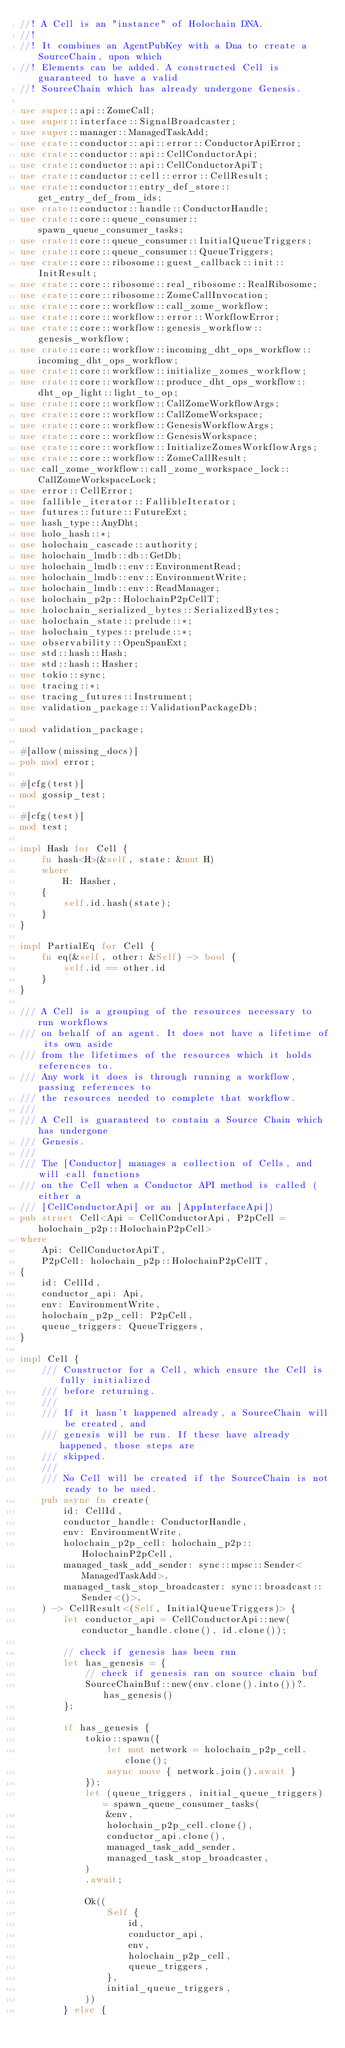<code> <loc_0><loc_0><loc_500><loc_500><_Rust_>//! A Cell is an "instance" of Holochain DNA.
//!
//! It combines an AgentPubKey with a Dna to create a SourceChain, upon which
//! Elements can be added. A constructed Cell is guaranteed to have a valid
//! SourceChain which has already undergone Genesis.

use super::api::ZomeCall;
use super::interface::SignalBroadcaster;
use super::manager::ManagedTaskAdd;
use crate::conductor::api::error::ConductorApiError;
use crate::conductor::api::CellConductorApi;
use crate::conductor::api::CellConductorApiT;
use crate::conductor::cell::error::CellResult;
use crate::conductor::entry_def_store::get_entry_def_from_ids;
use crate::conductor::handle::ConductorHandle;
use crate::core::queue_consumer::spawn_queue_consumer_tasks;
use crate::core::queue_consumer::InitialQueueTriggers;
use crate::core::queue_consumer::QueueTriggers;
use crate::core::ribosome::guest_callback::init::InitResult;
use crate::core::ribosome::real_ribosome::RealRibosome;
use crate::core::ribosome::ZomeCallInvocation;
use crate::core::workflow::call_zome_workflow;
use crate::core::workflow::error::WorkflowError;
use crate::core::workflow::genesis_workflow::genesis_workflow;
use crate::core::workflow::incoming_dht_ops_workflow::incoming_dht_ops_workflow;
use crate::core::workflow::initialize_zomes_workflow;
use crate::core::workflow::produce_dht_ops_workflow::dht_op_light::light_to_op;
use crate::core::workflow::CallZomeWorkflowArgs;
use crate::core::workflow::CallZomeWorkspace;
use crate::core::workflow::GenesisWorkflowArgs;
use crate::core::workflow::GenesisWorkspace;
use crate::core::workflow::InitializeZomesWorkflowArgs;
use crate::core::workflow::ZomeCallResult;
use call_zome_workflow::call_zome_workspace_lock::CallZomeWorkspaceLock;
use error::CellError;
use fallible_iterator::FallibleIterator;
use futures::future::FutureExt;
use hash_type::AnyDht;
use holo_hash::*;
use holochain_cascade::authority;
use holochain_lmdb::db::GetDb;
use holochain_lmdb::env::EnvironmentRead;
use holochain_lmdb::env::EnvironmentWrite;
use holochain_lmdb::env::ReadManager;
use holochain_p2p::HolochainP2pCellT;
use holochain_serialized_bytes::SerializedBytes;
use holochain_state::prelude::*;
use holochain_types::prelude::*;
use observability::OpenSpanExt;
use std::hash::Hash;
use std::hash::Hasher;
use tokio::sync;
use tracing::*;
use tracing_futures::Instrument;
use validation_package::ValidationPackageDb;

mod validation_package;

#[allow(missing_docs)]
pub mod error;

#[cfg(test)]
mod gossip_test;

#[cfg(test)]
mod test;

impl Hash for Cell {
    fn hash<H>(&self, state: &mut H)
    where
        H: Hasher,
    {
        self.id.hash(state);
    }
}

impl PartialEq for Cell {
    fn eq(&self, other: &Self) -> bool {
        self.id == other.id
    }
}

/// A Cell is a grouping of the resources necessary to run workflows
/// on behalf of an agent. It does not have a lifetime of its own aside
/// from the lifetimes of the resources which it holds references to.
/// Any work it does is through running a workflow, passing references to
/// the resources needed to complete that workflow.
///
/// A Cell is guaranteed to contain a Source Chain which has undergone
/// Genesis.
///
/// The [Conductor] manages a collection of Cells, and will call functions
/// on the Cell when a Conductor API method is called (either a
/// [CellConductorApi] or an [AppInterfaceApi])
pub struct Cell<Api = CellConductorApi, P2pCell = holochain_p2p::HolochainP2pCell>
where
    Api: CellConductorApiT,
    P2pCell: holochain_p2p::HolochainP2pCellT,
{
    id: CellId,
    conductor_api: Api,
    env: EnvironmentWrite,
    holochain_p2p_cell: P2pCell,
    queue_triggers: QueueTriggers,
}

impl Cell {
    /// Constructor for a Cell, which ensure the Cell is fully initialized
    /// before returning.
    ///
    /// If it hasn't happened already, a SourceChain will be created, and
    /// genesis will be run. If these have already happened, those steps are
    /// skipped.
    ///
    /// No Cell will be created if the SourceChain is not ready to be used.
    pub async fn create(
        id: CellId,
        conductor_handle: ConductorHandle,
        env: EnvironmentWrite,
        holochain_p2p_cell: holochain_p2p::HolochainP2pCell,
        managed_task_add_sender: sync::mpsc::Sender<ManagedTaskAdd>,
        managed_task_stop_broadcaster: sync::broadcast::Sender<()>,
    ) -> CellResult<(Self, InitialQueueTriggers)> {
        let conductor_api = CellConductorApi::new(conductor_handle.clone(), id.clone());

        // check if genesis has been run
        let has_genesis = {
            // check if genesis ran on source chain buf
            SourceChainBuf::new(env.clone().into())?.has_genesis()
        };

        if has_genesis {
            tokio::spawn({
                let mut network = holochain_p2p_cell.clone();
                async move { network.join().await }
            });
            let (queue_triggers, initial_queue_triggers) = spawn_queue_consumer_tasks(
                &env,
                holochain_p2p_cell.clone(),
                conductor_api.clone(),
                managed_task_add_sender,
                managed_task_stop_broadcaster,
            )
            .await;

            Ok((
                Self {
                    id,
                    conductor_api,
                    env,
                    holochain_p2p_cell,
                    queue_triggers,
                },
                initial_queue_triggers,
            ))
        } else {</code> 